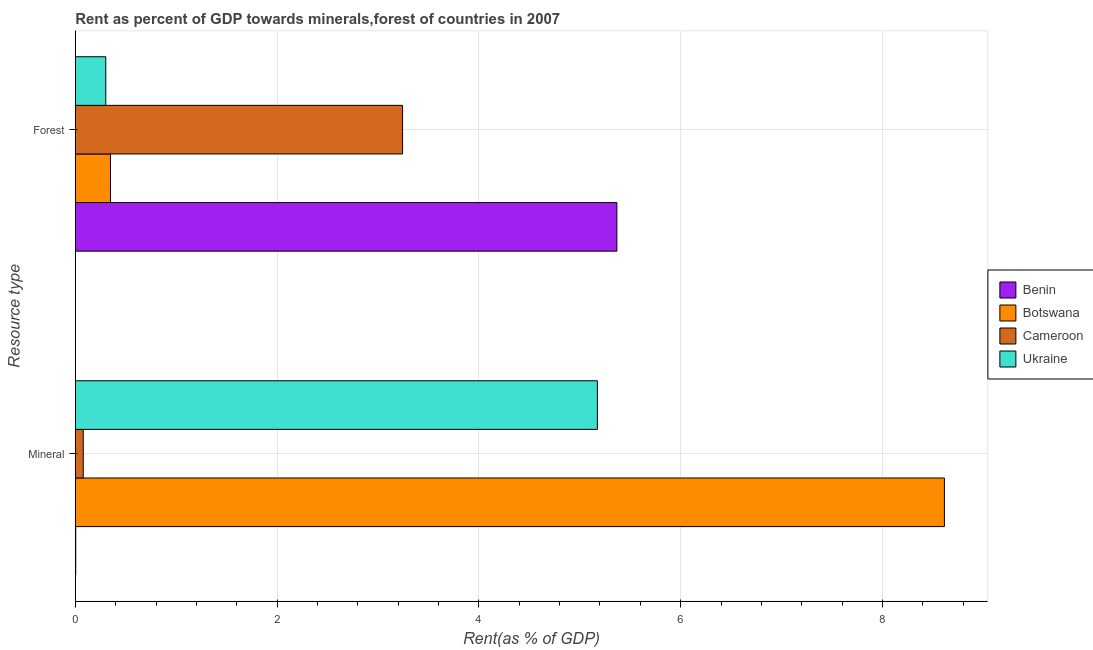How many different coloured bars are there?
Your answer should be compact. 4. How many bars are there on the 1st tick from the bottom?
Your answer should be compact. 4. What is the label of the 2nd group of bars from the top?
Make the answer very short. Mineral. What is the forest rent in Botswana?
Ensure brevity in your answer.  0.35. Across all countries, what is the maximum forest rent?
Provide a short and direct response. 5.37. Across all countries, what is the minimum mineral rent?
Offer a very short reply. 0. In which country was the mineral rent maximum?
Make the answer very short. Botswana. In which country was the mineral rent minimum?
Your response must be concise. Benin. What is the total forest rent in the graph?
Make the answer very short. 9.26. What is the difference between the mineral rent in Botswana and that in Benin?
Keep it short and to the point. 8.61. What is the difference between the forest rent in Benin and the mineral rent in Ukraine?
Your response must be concise. 0.19. What is the average mineral rent per country?
Your answer should be compact. 3.47. What is the difference between the mineral rent and forest rent in Botswana?
Provide a short and direct response. 8.27. In how many countries, is the forest rent greater than 6 %?
Provide a short and direct response. 0. What is the ratio of the mineral rent in Cameroon to that in Ukraine?
Provide a succinct answer. 0.02. In how many countries, is the forest rent greater than the average forest rent taken over all countries?
Your answer should be very brief. 2. What does the 3rd bar from the top in Mineral represents?
Ensure brevity in your answer.  Botswana. What does the 1st bar from the bottom in Forest represents?
Your answer should be very brief. Benin. How many bars are there?
Your answer should be compact. 8. Are all the bars in the graph horizontal?
Offer a terse response. Yes. Are the values on the major ticks of X-axis written in scientific E-notation?
Offer a very short reply. No. Does the graph contain any zero values?
Offer a terse response. No. Does the graph contain grids?
Provide a succinct answer. Yes. Where does the legend appear in the graph?
Your response must be concise. Center right. How many legend labels are there?
Your answer should be compact. 4. What is the title of the graph?
Give a very brief answer. Rent as percent of GDP towards minerals,forest of countries in 2007. Does "Hong Kong" appear as one of the legend labels in the graph?
Offer a very short reply. No. What is the label or title of the X-axis?
Provide a succinct answer. Rent(as % of GDP). What is the label or title of the Y-axis?
Give a very brief answer. Resource type. What is the Rent(as % of GDP) of Benin in Mineral?
Ensure brevity in your answer.  0. What is the Rent(as % of GDP) in Botswana in Mineral?
Offer a terse response. 8.61. What is the Rent(as % of GDP) of Cameroon in Mineral?
Offer a very short reply. 0.08. What is the Rent(as % of GDP) of Ukraine in Mineral?
Provide a short and direct response. 5.17. What is the Rent(as % of GDP) of Benin in Forest?
Your answer should be compact. 5.37. What is the Rent(as % of GDP) of Botswana in Forest?
Give a very brief answer. 0.35. What is the Rent(as % of GDP) in Cameroon in Forest?
Provide a succinct answer. 3.24. What is the Rent(as % of GDP) of Ukraine in Forest?
Offer a terse response. 0.3. Across all Resource type, what is the maximum Rent(as % of GDP) of Benin?
Your response must be concise. 5.37. Across all Resource type, what is the maximum Rent(as % of GDP) in Botswana?
Ensure brevity in your answer.  8.61. Across all Resource type, what is the maximum Rent(as % of GDP) of Cameroon?
Your answer should be compact. 3.24. Across all Resource type, what is the maximum Rent(as % of GDP) of Ukraine?
Provide a succinct answer. 5.17. Across all Resource type, what is the minimum Rent(as % of GDP) of Benin?
Your response must be concise. 0. Across all Resource type, what is the minimum Rent(as % of GDP) in Botswana?
Offer a terse response. 0.35. Across all Resource type, what is the minimum Rent(as % of GDP) in Cameroon?
Ensure brevity in your answer.  0.08. Across all Resource type, what is the minimum Rent(as % of GDP) in Ukraine?
Ensure brevity in your answer.  0.3. What is the total Rent(as % of GDP) of Benin in the graph?
Give a very brief answer. 5.37. What is the total Rent(as % of GDP) of Botswana in the graph?
Offer a very short reply. 8.96. What is the total Rent(as % of GDP) of Cameroon in the graph?
Make the answer very short. 3.32. What is the total Rent(as % of GDP) of Ukraine in the graph?
Offer a very short reply. 5.48. What is the difference between the Rent(as % of GDP) in Benin in Mineral and that in Forest?
Make the answer very short. -5.36. What is the difference between the Rent(as % of GDP) in Botswana in Mineral and that in Forest?
Your answer should be very brief. 8.27. What is the difference between the Rent(as % of GDP) of Cameroon in Mineral and that in Forest?
Your response must be concise. -3.17. What is the difference between the Rent(as % of GDP) of Ukraine in Mineral and that in Forest?
Give a very brief answer. 4.87. What is the difference between the Rent(as % of GDP) of Benin in Mineral and the Rent(as % of GDP) of Botswana in Forest?
Provide a short and direct response. -0.34. What is the difference between the Rent(as % of GDP) in Benin in Mineral and the Rent(as % of GDP) in Cameroon in Forest?
Ensure brevity in your answer.  -3.24. What is the difference between the Rent(as % of GDP) in Benin in Mineral and the Rent(as % of GDP) in Ukraine in Forest?
Your answer should be compact. -0.3. What is the difference between the Rent(as % of GDP) in Botswana in Mineral and the Rent(as % of GDP) in Cameroon in Forest?
Provide a short and direct response. 5.37. What is the difference between the Rent(as % of GDP) in Botswana in Mineral and the Rent(as % of GDP) in Ukraine in Forest?
Give a very brief answer. 8.31. What is the difference between the Rent(as % of GDP) in Cameroon in Mineral and the Rent(as % of GDP) in Ukraine in Forest?
Offer a terse response. -0.22. What is the average Rent(as % of GDP) in Benin per Resource type?
Provide a short and direct response. 2.69. What is the average Rent(as % of GDP) of Botswana per Resource type?
Give a very brief answer. 4.48. What is the average Rent(as % of GDP) of Cameroon per Resource type?
Ensure brevity in your answer.  1.66. What is the average Rent(as % of GDP) in Ukraine per Resource type?
Your answer should be compact. 2.74. What is the difference between the Rent(as % of GDP) in Benin and Rent(as % of GDP) in Botswana in Mineral?
Your answer should be very brief. -8.61. What is the difference between the Rent(as % of GDP) in Benin and Rent(as % of GDP) in Cameroon in Mineral?
Your response must be concise. -0.07. What is the difference between the Rent(as % of GDP) of Benin and Rent(as % of GDP) of Ukraine in Mineral?
Keep it short and to the point. -5.17. What is the difference between the Rent(as % of GDP) in Botswana and Rent(as % of GDP) in Cameroon in Mineral?
Make the answer very short. 8.54. What is the difference between the Rent(as % of GDP) of Botswana and Rent(as % of GDP) of Ukraine in Mineral?
Make the answer very short. 3.44. What is the difference between the Rent(as % of GDP) of Cameroon and Rent(as % of GDP) of Ukraine in Mineral?
Offer a terse response. -5.1. What is the difference between the Rent(as % of GDP) of Benin and Rent(as % of GDP) of Botswana in Forest?
Your answer should be very brief. 5.02. What is the difference between the Rent(as % of GDP) in Benin and Rent(as % of GDP) in Cameroon in Forest?
Keep it short and to the point. 2.12. What is the difference between the Rent(as % of GDP) of Benin and Rent(as % of GDP) of Ukraine in Forest?
Your response must be concise. 5.07. What is the difference between the Rent(as % of GDP) in Botswana and Rent(as % of GDP) in Cameroon in Forest?
Your answer should be very brief. -2.9. What is the difference between the Rent(as % of GDP) in Botswana and Rent(as % of GDP) in Ukraine in Forest?
Make the answer very short. 0.05. What is the difference between the Rent(as % of GDP) in Cameroon and Rent(as % of GDP) in Ukraine in Forest?
Your response must be concise. 2.94. What is the ratio of the Rent(as % of GDP) in Benin in Mineral to that in Forest?
Provide a succinct answer. 0. What is the ratio of the Rent(as % of GDP) of Botswana in Mineral to that in Forest?
Keep it short and to the point. 24.69. What is the ratio of the Rent(as % of GDP) of Cameroon in Mineral to that in Forest?
Your answer should be compact. 0.02. What is the ratio of the Rent(as % of GDP) in Ukraine in Mineral to that in Forest?
Offer a very short reply. 17.13. What is the difference between the highest and the second highest Rent(as % of GDP) of Benin?
Your answer should be compact. 5.36. What is the difference between the highest and the second highest Rent(as % of GDP) of Botswana?
Your response must be concise. 8.27. What is the difference between the highest and the second highest Rent(as % of GDP) of Cameroon?
Offer a terse response. 3.17. What is the difference between the highest and the second highest Rent(as % of GDP) of Ukraine?
Ensure brevity in your answer.  4.87. What is the difference between the highest and the lowest Rent(as % of GDP) in Benin?
Offer a terse response. 5.36. What is the difference between the highest and the lowest Rent(as % of GDP) of Botswana?
Your response must be concise. 8.27. What is the difference between the highest and the lowest Rent(as % of GDP) in Cameroon?
Provide a short and direct response. 3.17. What is the difference between the highest and the lowest Rent(as % of GDP) of Ukraine?
Offer a terse response. 4.87. 